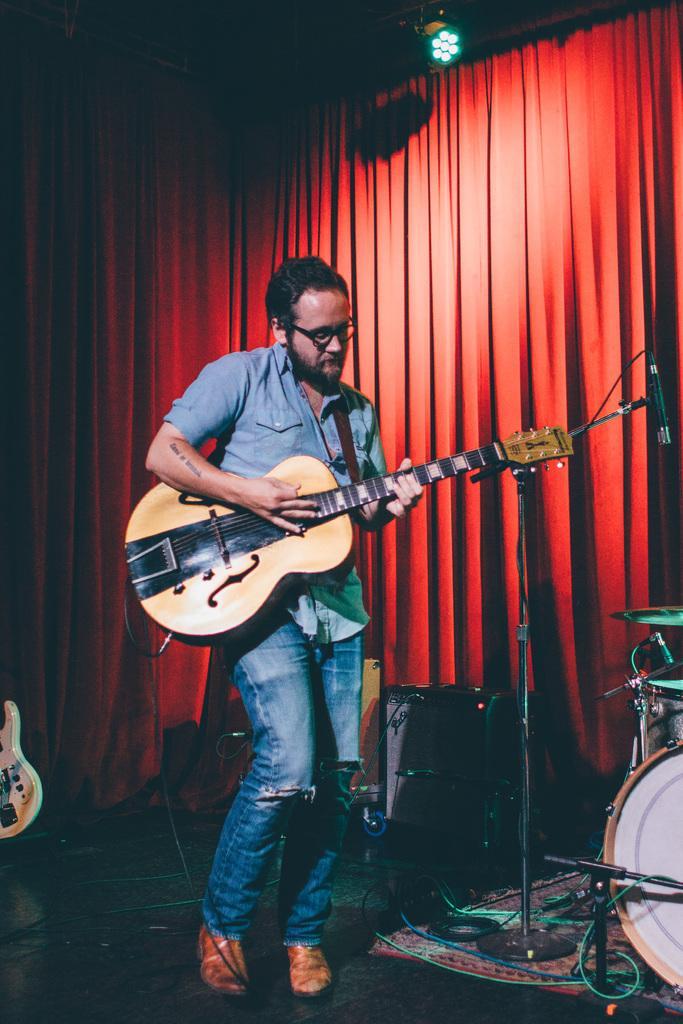Describe this image in one or two sentences. Here we see a man playing a guitar. 